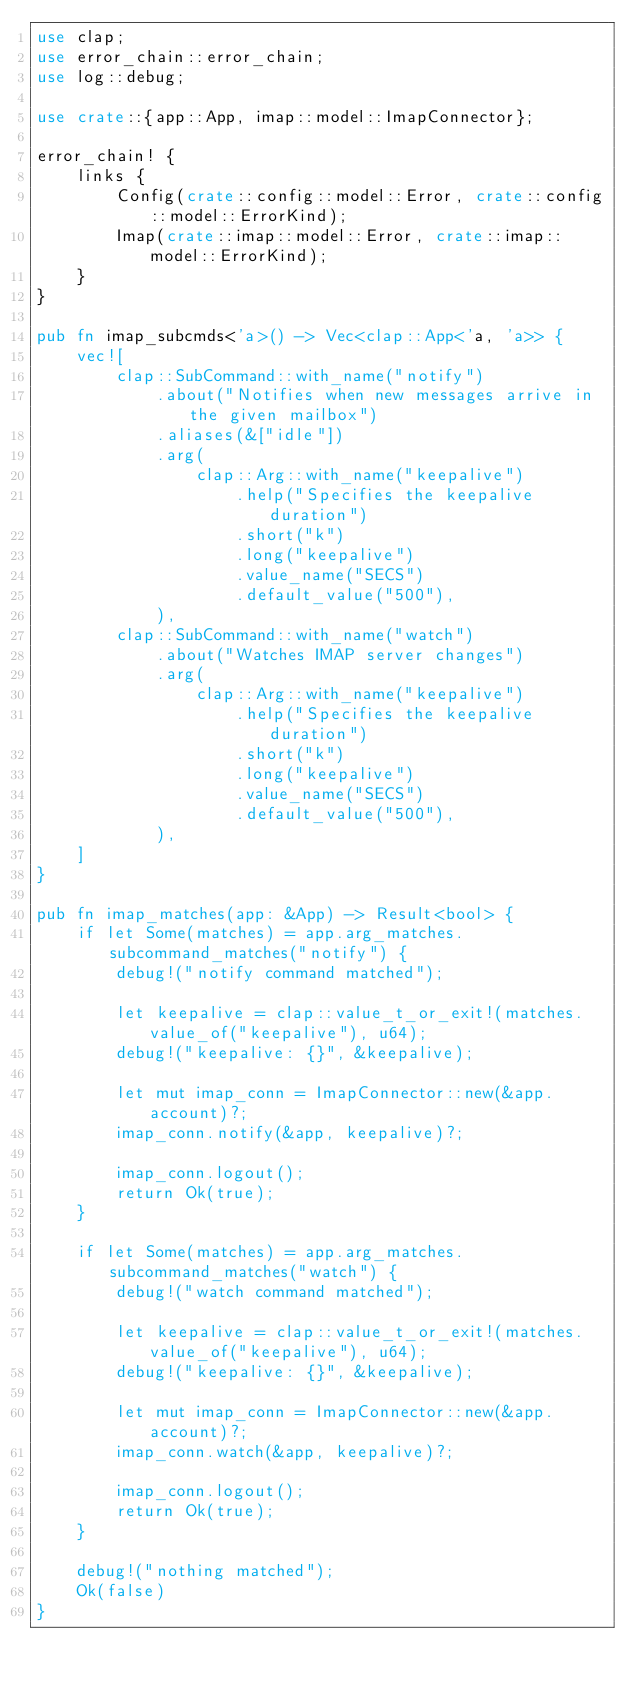<code> <loc_0><loc_0><loc_500><loc_500><_Rust_>use clap;
use error_chain::error_chain;
use log::debug;

use crate::{app::App, imap::model::ImapConnector};

error_chain! {
    links {
        Config(crate::config::model::Error, crate::config::model::ErrorKind);
        Imap(crate::imap::model::Error, crate::imap::model::ErrorKind);
    }
}

pub fn imap_subcmds<'a>() -> Vec<clap::App<'a, 'a>> {
    vec![
        clap::SubCommand::with_name("notify")
            .about("Notifies when new messages arrive in the given mailbox")
            .aliases(&["idle"])
            .arg(
                clap::Arg::with_name("keepalive")
                    .help("Specifies the keepalive duration")
                    .short("k")
                    .long("keepalive")
                    .value_name("SECS")
                    .default_value("500"),
            ),
        clap::SubCommand::with_name("watch")
            .about("Watches IMAP server changes")
            .arg(
                clap::Arg::with_name("keepalive")
                    .help("Specifies the keepalive duration")
                    .short("k")
                    .long("keepalive")
                    .value_name("SECS")
                    .default_value("500"),
            ),
    ]
}

pub fn imap_matches(app: &App) -> Result<bool> {
    if let Some(matches) = app.arg_matches.subcommand_matches("notify") {
        debug!("notify command matched");

        let keepalive = clap::value_t_or_exit!(matches.value_of("keepalive"), u64);
        debug!("keepalive: {}", &keepalive);

        let mut imap_conn = ImapConnector::new(&app.account)?;
        imap_conn.notify(&app, keepalive)?;

        imap_conn.logout();
        return Ok(true);
    }

    if let Some(matches) = app.arg_matches.subcommand_matches("watch") {
        debug!("watch command matched");

        let keepalive = clap::value_t_or_exit!(matches.value_of("keepalive"), u64);
        debug!("keepalive: {}", &keepalive);

        let mut imap_conn = ImapConnector::new(&app.account)?;
        imap_conn.watch(&app, keepalive)?;

        imap_conn.logout();
        return Ok(true);
    }

    debug!("nothing matched");
    Ok(false)
}
</code> 